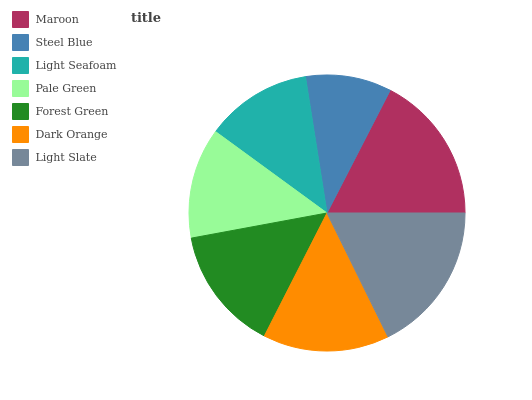Is Steel Blue the minimum?
Answer yes or no. Yes. Is Light Slate the maximum?
Answer yes or no. Yes. Is Light Seafoam the minimum?
Answer yes or no. No. Is Light Seafoam the maximum?
Answer yes or no. No. Is Light Seafoam greater than Steel Blue?
Answer yes or no. Yes. Is Steel Blue less than Light Seafoam?
Answer yes or no. Yes. Is Steel Blue greater than Light Seafoam?
Answer yes or no. No. Is Light Seafoam less than Steel Blue?
Answer yes or no. No. Is Forest Green the high median?
Answer yes or no. Yes. Is Forest Green the low median?
Answer yes or no. Yes. Is Pale Green the high median?
Answer yes or no. No. Is Light Slate the low median?
Answer yes or no. No. 